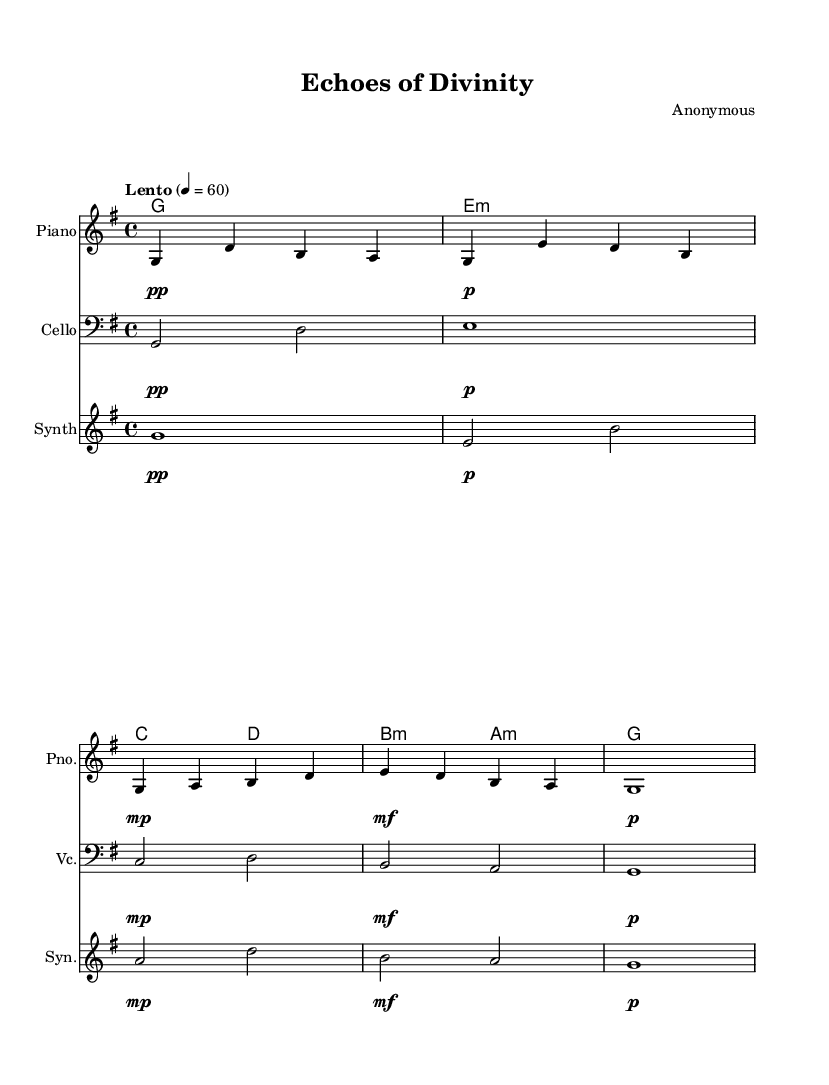What is the key signature of this music? The key signature is G major, which has one sharp (F#). This can be determined by examining the key signature indicated at the beginning of the score.
Answer: G major What is the time signature of this piece? The time signature is 4/4, which indicates there are four beats in each measure. This is visible at the beginning of the staff notation.
Answer: 4/4 What is the tempo marking for this piece? The tempo marking is "Lento", indicating it should be played slowly. This is found written above the staff in the tempo notation.
Answer: Lento Which instrument plays the lowest part? The cello plays the lowest part in terms of pitch range, as it has a bass clef and the notes are lower than those of the piano and synth. This can be seen from the clef and the specific notes in its staff.
Answer: Cello How many measures are in the piano part? The piano part contains four measures, which can be counted visually by looking at the division of the music staff into distinct measure bars.
Answer: Four What dynamics are used in the cello part? The dynamics in the cello part include pianissimo, piano, mezzo-piano, mezzo-forte, and piano, as indicated by the dynamic markings placed above corresponding notes.
Answer: Pianissimo, piano, mezzo-piano, mezzo-forte, piano What is the main theme of this composition? The main theme revolves around ambient instrumental music inspired by sacred architecture, highlighted through its melodic and harmonic structures that evoke a sense of space and atmosphere. This understanding can be derived from the title and the nature of the music itself.
Answer: Ambient instrumental 